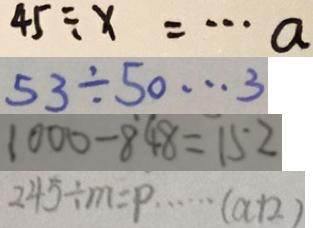Convert formula to latex. <formula><loc_0><loc_0><loc_500><loc_500>4 5 \div x = \cdots a 
 5 3 \div 5 0 \cdots 3 
 1 0 0 0 - 8 4 8 = 1 5 2 
 2 4 5 \div m = p \cdots ( a + 2 )</formula> 